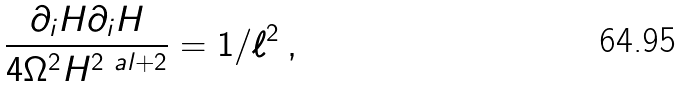<formula> <loc_0><loc_0><loc_500><loc_500>\frac { \partial _ { i } H \partial _ { i } H } { 4 \Omega ^ { 2 } H ^ { 2 \ a l + 2 } } = 1 / \ell ^ { 2 } \, ,</formula> 